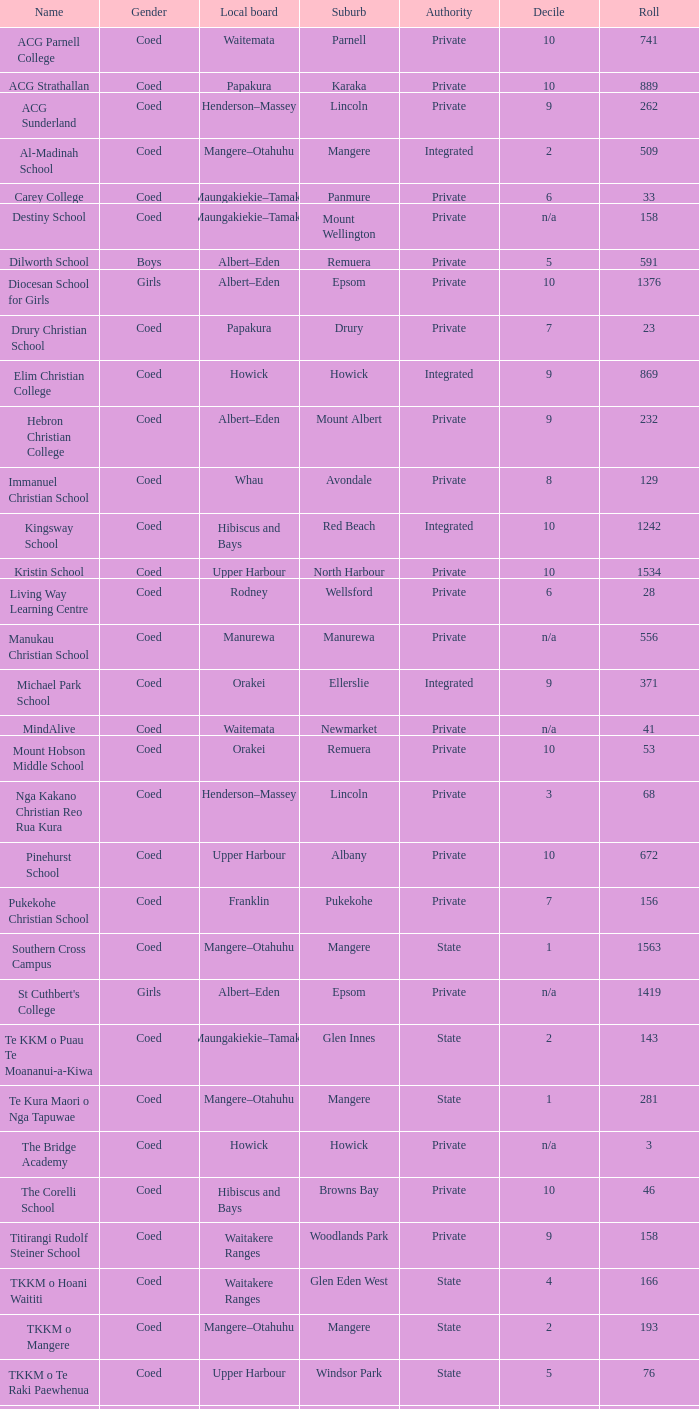Can you identify the suburb that has a roll of 741? Parnell. 